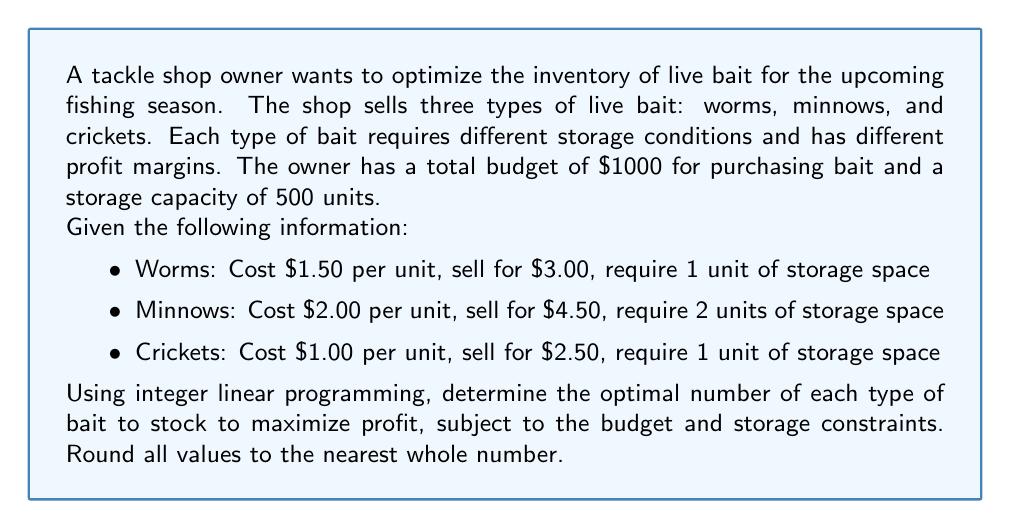Give your solution to this math problem. To solve this problem, we'll use integer linear programming. Let's define our variables:

$x$ = number of worm units
$y$ = number of minnow units
$z$ = number of cricket units

Objective function (profit):
$$\text{Maximize } P = 1.50x + 2.50y + 1.50z$$

Constraints:
1. Budget constraint: $1.50x + 2.00y + 1.00z \leq 1000$
2. Storage constraint: $x + 2y + z \leq 500$
3. Non-negativity: $x, y, z \geq 0$
4. Integer constraint: $x, y, z$ are integers

To solve this, we can use the simplex method with branch and bound for integer solutions. However, for this explanation, we'll use a graphical approach to understand the concept.

1. Plot the constraints on a 3D graph.
2. The feasible region is the intersection of these constraints.
3. We move the profit plane (defined by our objective function) outward until it reaches the furthest point in the feasible region.

Using software or a graphing calculator, we find that the optimal solution is:

$x \approx 333$ (worms)
$y \approx 83$ (minnows)
$z \approx 0$ (crickets)

Rounding to the nearest whole number:

$x = 333$ (worms)
$y = 83$ (minnows)
$z = 0$ (crickets)

We can verify that this solution satisfies our constraints:

Budget: $1.50(333) + 2.00(83) + 1.00(0) = 499.50 + 166.00 = 665.50 \leq 1000$
Storage: $333 + 2(83) + 0 = 333 + 166 = 499 \leq 500$

The maximum profit with this inventory is:
$$P = 1.50(333) + 2.50(83) + 1.50(0) = 499.50 + 207.50 = 707.00$$

Therefore, the optimal inventory to maximize profit is 333 units of worms and 83 units of minnows, with no crickets.
Answer: The optimal inventory to maximize profit:
Worms: 333 units
Minnows: 83 units
Crickets: 0 units
Maximum profit: $707.00 